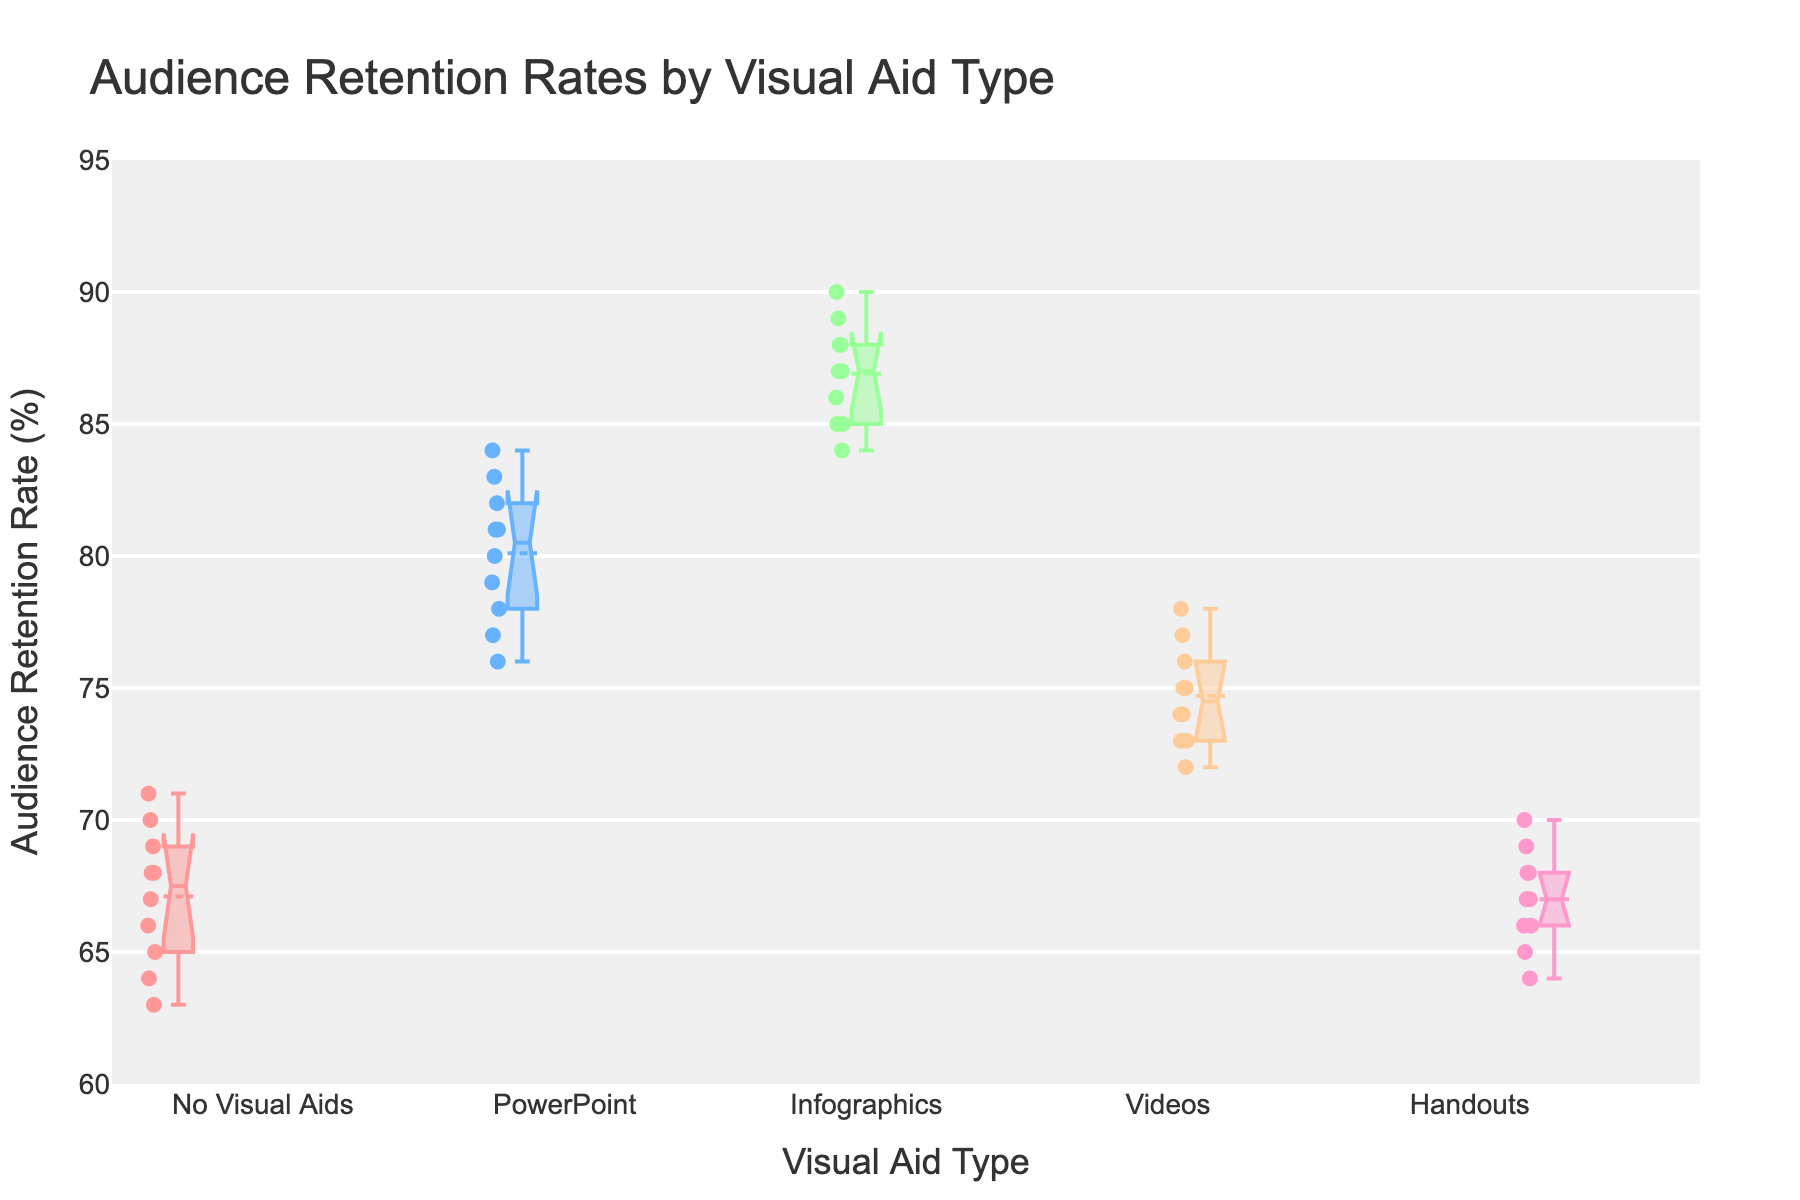What's the title of the figure? The title is usually displayed prominently at the top of the figure. In this case, the title is shown as 'Audience Retention Rates by Visual Aid Type'.
Answer: Audience Retention Rates by Visual Aid Type How many different visual aid types are displayed in the figure? The different visual aid types are represented by the labels on the x-axis. Each label corresponds to a unique type of visual aid.
Answer: 5 Which visual aid type has the highest mean audience retention rate? Inspecting the notched box plot, the mean is typically depicted by the line within the box. Among all the visual aid types, 'Infographics' shows the highest mean audience retention rate.
Answer: Infographics What is the interquartile range (IQR) for the 'Videos' visual aid type? The IQR is the range between the first quartile (25th percentile) and the third quartile (75th percentile). For 'Videos', this is represented by the length of the box from the bottom to the top boundaries within each visual aid type box plot.
Answer: 74 to 76 What is the median audience retention rate for 'PowerPoint' presentations? The median is the line within the box. For 'PowerPoint' presentations, the median is represented by the line inside the respective box plot.
Answer: 80 Are there any outliers in the 'No Visual Aids' data, and if so, how many? Outliers in box plots are typically represented as individual points outside the 'whiskers'. Here, we need to count any points outside the whiskers for the 'No Visual Aids' category.
Answer: No, there are no outliers Is the audience retention rate more variable for 'Handouts' or 'PowerPoint' presentations? The variability can be judged by the length of the box and the whiskers. 'Handouts' show a wider spread from the minimum to the maximum value compared to 'PowerPoint'.
Answer: Handouts Which visual aid type has the smallest range in audience retention rates? The range is the difference between the maximum and minimum values. Observing the box plots, 'Videos' has the smallest spread from min to max.
Answer: Videos Is the mean retention rate for 'No Visual Aids' greater than 'Videos'? From the box plots, the mean is displayed as a line within the box. Comparing the means, 'No Visual Aids' has a lower mean than 'Videos'.
Answer: No Which visual aid type has the highest maximum audience retention rate? The maximum value is shown by the highest whisker point. Among all visual aid types, 'Infographics' reaches the highest maximum value.
Answer: Infographics 